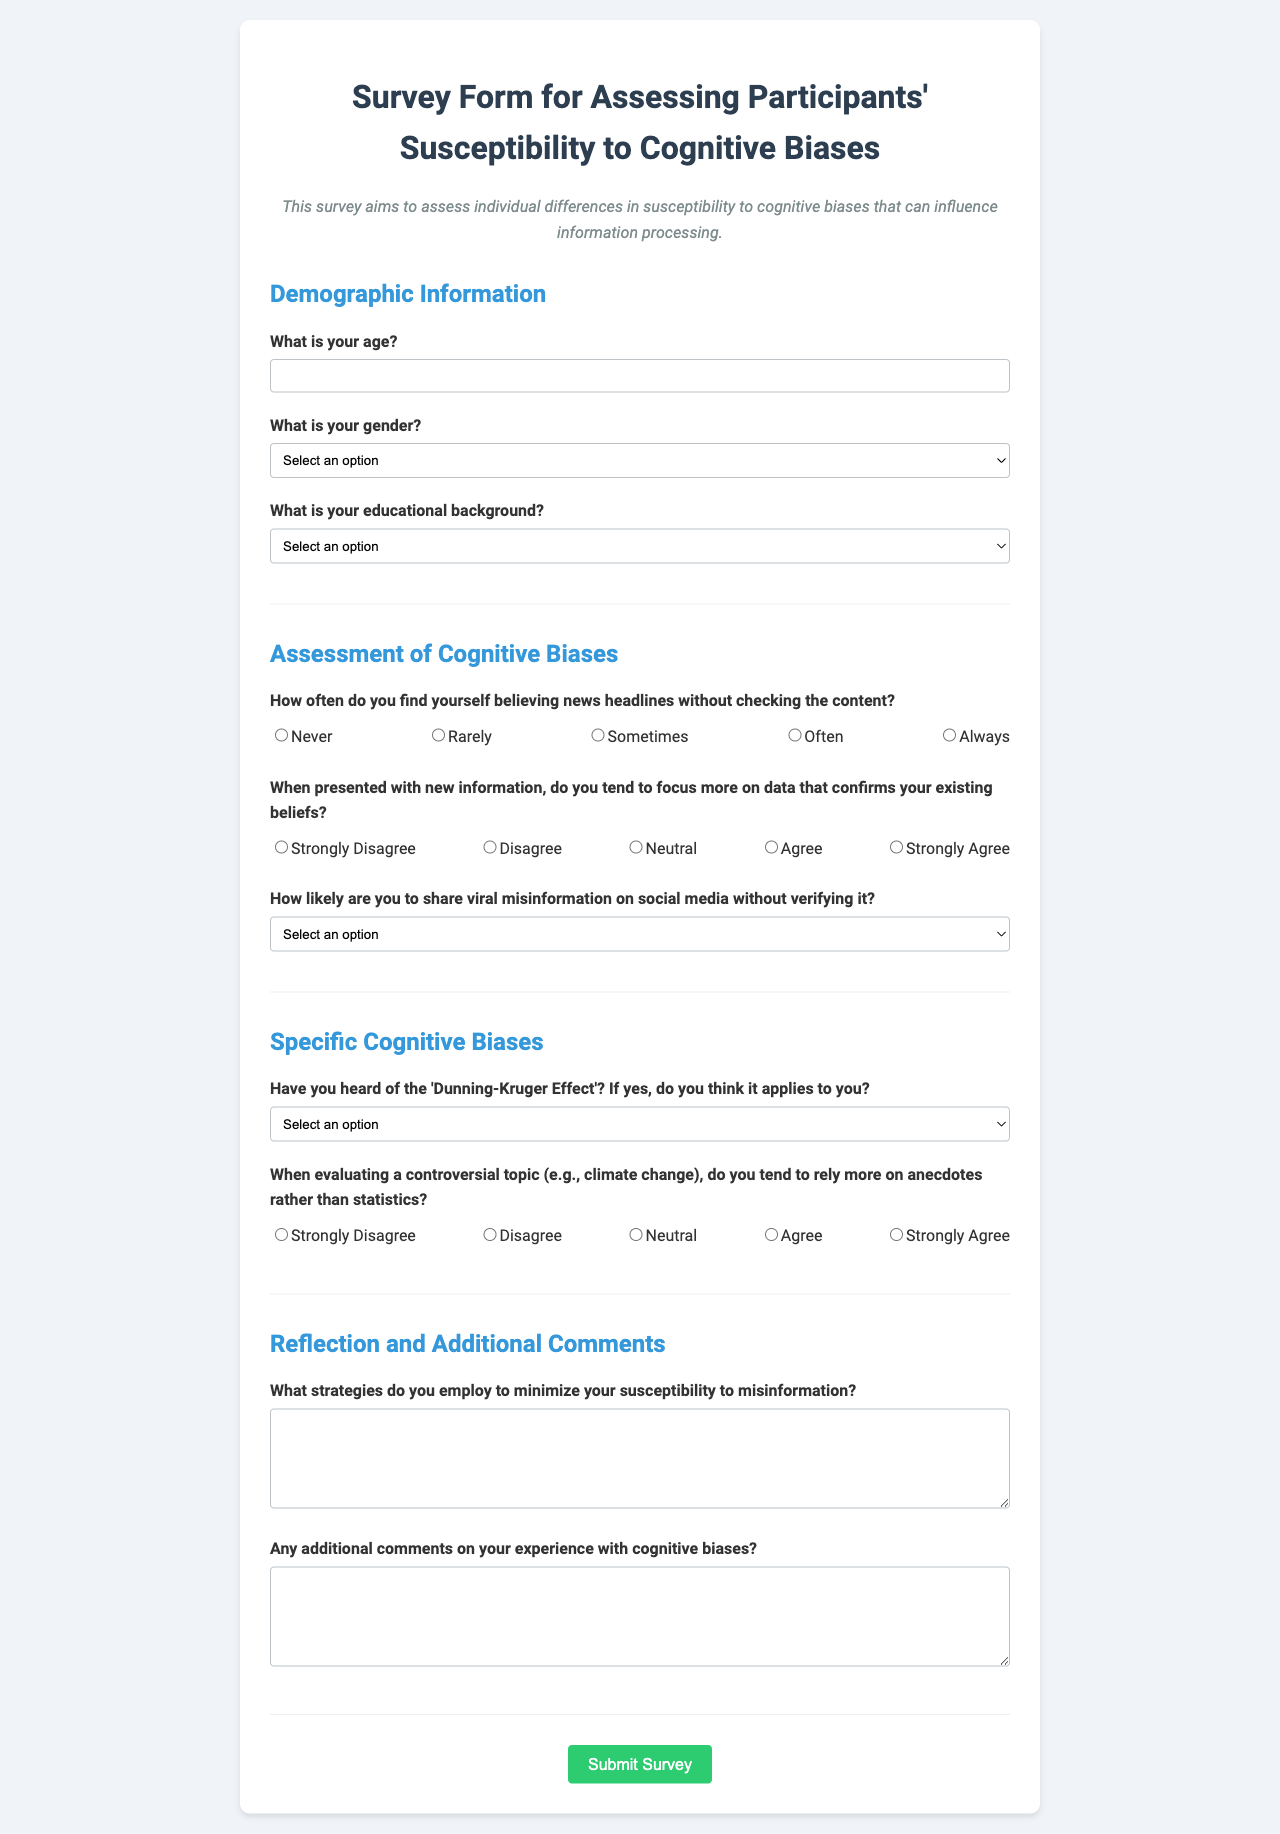What is the title of the survey form? The title is prominently displayed at the top of the document, providing the focus of the survey.
Answer: Survey Form for Assessing Participants' Susceptibility to Cognitive Biases What is the required response for age? The age question requires a numeric input, indicating that it must be filled out with a number.
Answer: Required numeric input What is the gender selection option that allows participants to remain anonymous? The gender section includes an option for those who may not wish to disclose their gender.
Answer: Prefer not to say How often do you find yourself believing news headlines without checking the content? This question assesses the frequency of participants' tendencies related to information verification and includes a scale response.
Answer: Scale response from 1 to 5 According to the survey, how should participants respond to the question about the Dunning-Kruger Effect? This question asks participants about their awareness and perception of their own tendencies related to the Dunning-Kruger Effect with multiple-choice options.
Answer: Select an option What is asked in the additional comments section of the survey? This section encourages participants to provide further insights about their experiences with cognitive biases, allowing for open-ended responses.
Answer: Additional comments on your experience with cognitive biases What is one strategy participants should indicate for minimizing susceptibility to misinformation? This open-ended question allows participants to describe their approaches to combat misinformation.
Answer: Strategies to minimize susceptibility How many sections are there in the survey form? The document is organized into distinct sections, each focusing on different aspects of the survey.
Answer: Four sections 